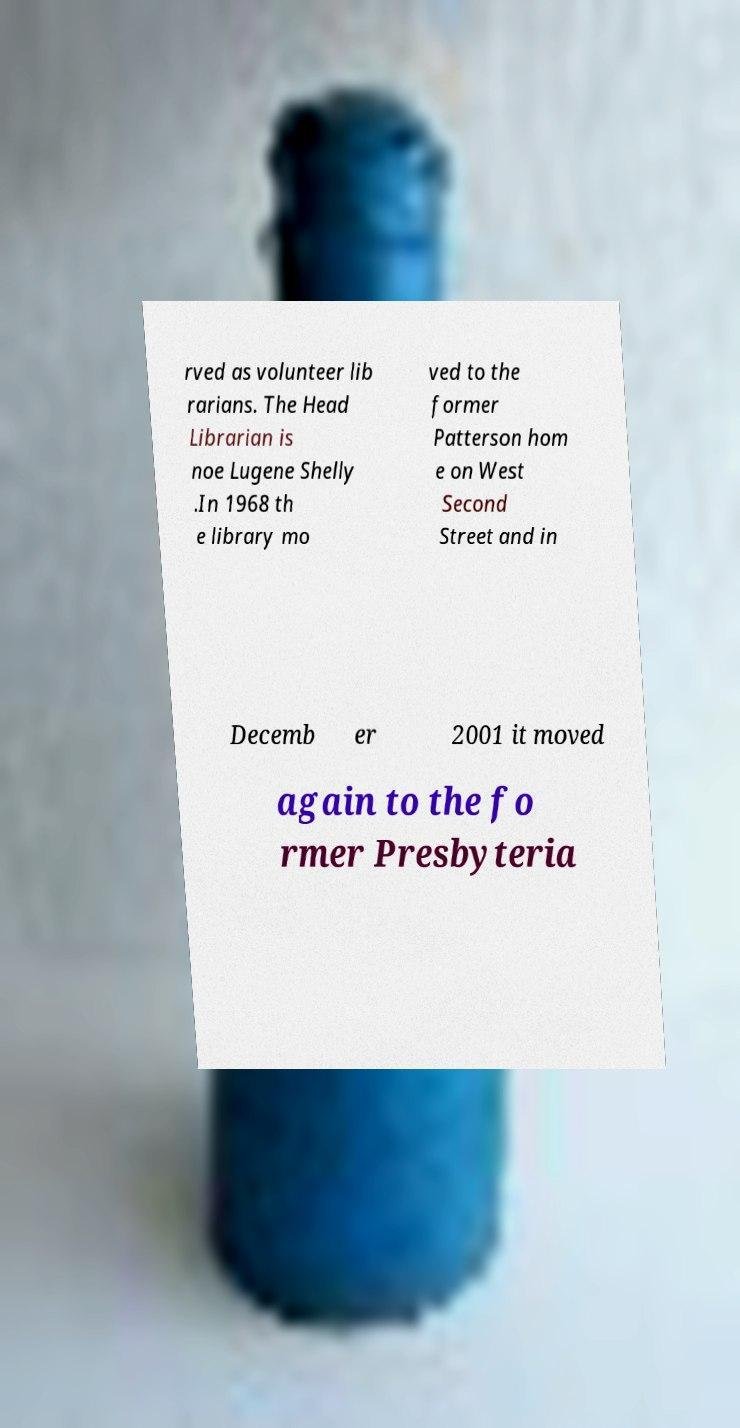What messages or text are displayed in this image? I need them in a readable, typed format. rved as volunteer lib rarians. The Head Librarian is noe Lugene Shelly .In 1968 th e library mo ved to the former Patterson hom e on West Second Street and in Decemb er 2001 it moved again to the fo rmer Presbyteria 